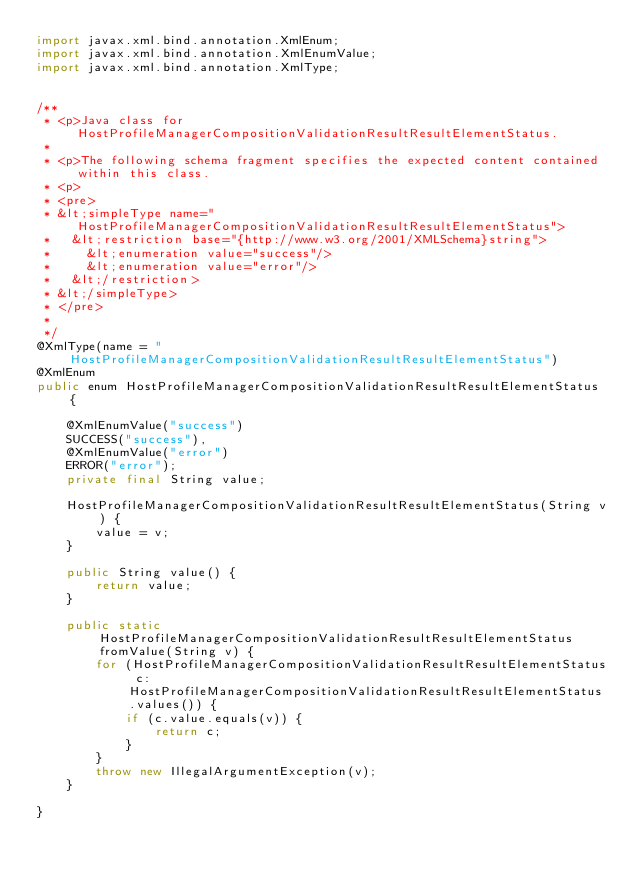Convert code to text. <code><loc_0><loc_0><loc_500><loc_500><_Java_>import javax.xml.bind.annotation.XmlEnum;
import javax.xml.bind.annotation.XmlEnumValue;
import javax.xml.bind.annotation.XmlType;


/**
 * <p>Java class for HostProfileManagerCompositionValidationResultResultElementStatus.
 * 
 * <p>The following schema fragment specifies the expected content contained within this class.
 * <p>
 * <pre>
 * &lt;simpleType name="HostProfileManagerCompositionValidationResultResultElementStatus">
 *   &lt;restriction base="{http://www.w3.org/2001/XMLSchema}string">
 *     &lt;enumeration value="success"/>
 *     &lt;enumeration value="error"/>
 *   &lt;/restriction>
 * &lt;/simpleType>
 * </pre>
 * 
 */
@XmlType(name = "HostProfileManagerCompositionValidationResultResultElementStatus")
@XmlEnum
public enum HostProfileManagerCompositionValidationResultResultElementStatus {

    @XmlEnumValue("success")
    SUCCESS("success"),
    @XmlEnumValue("error")
    ERROR("error");
    private final String value;

    HostProfileManagerCompositionValidationResultResultElementStatus(String v) {
        value = v;
    }

    public String value() {
        return value;
    }

    public static HostProfileManagerCompositionValidationResultResultElementStatus fromValue(String v) {
        for (HostProfileManagerCompositionValidationResultResultElementStatus c: HostProfileManagerCompositionValidationResultResultElementStatus.values()) {
            if (c.value.equals(v)) {
                return c;
            }
        }
        throw new IllegalArgumentException(v);
    }

}
</code> 